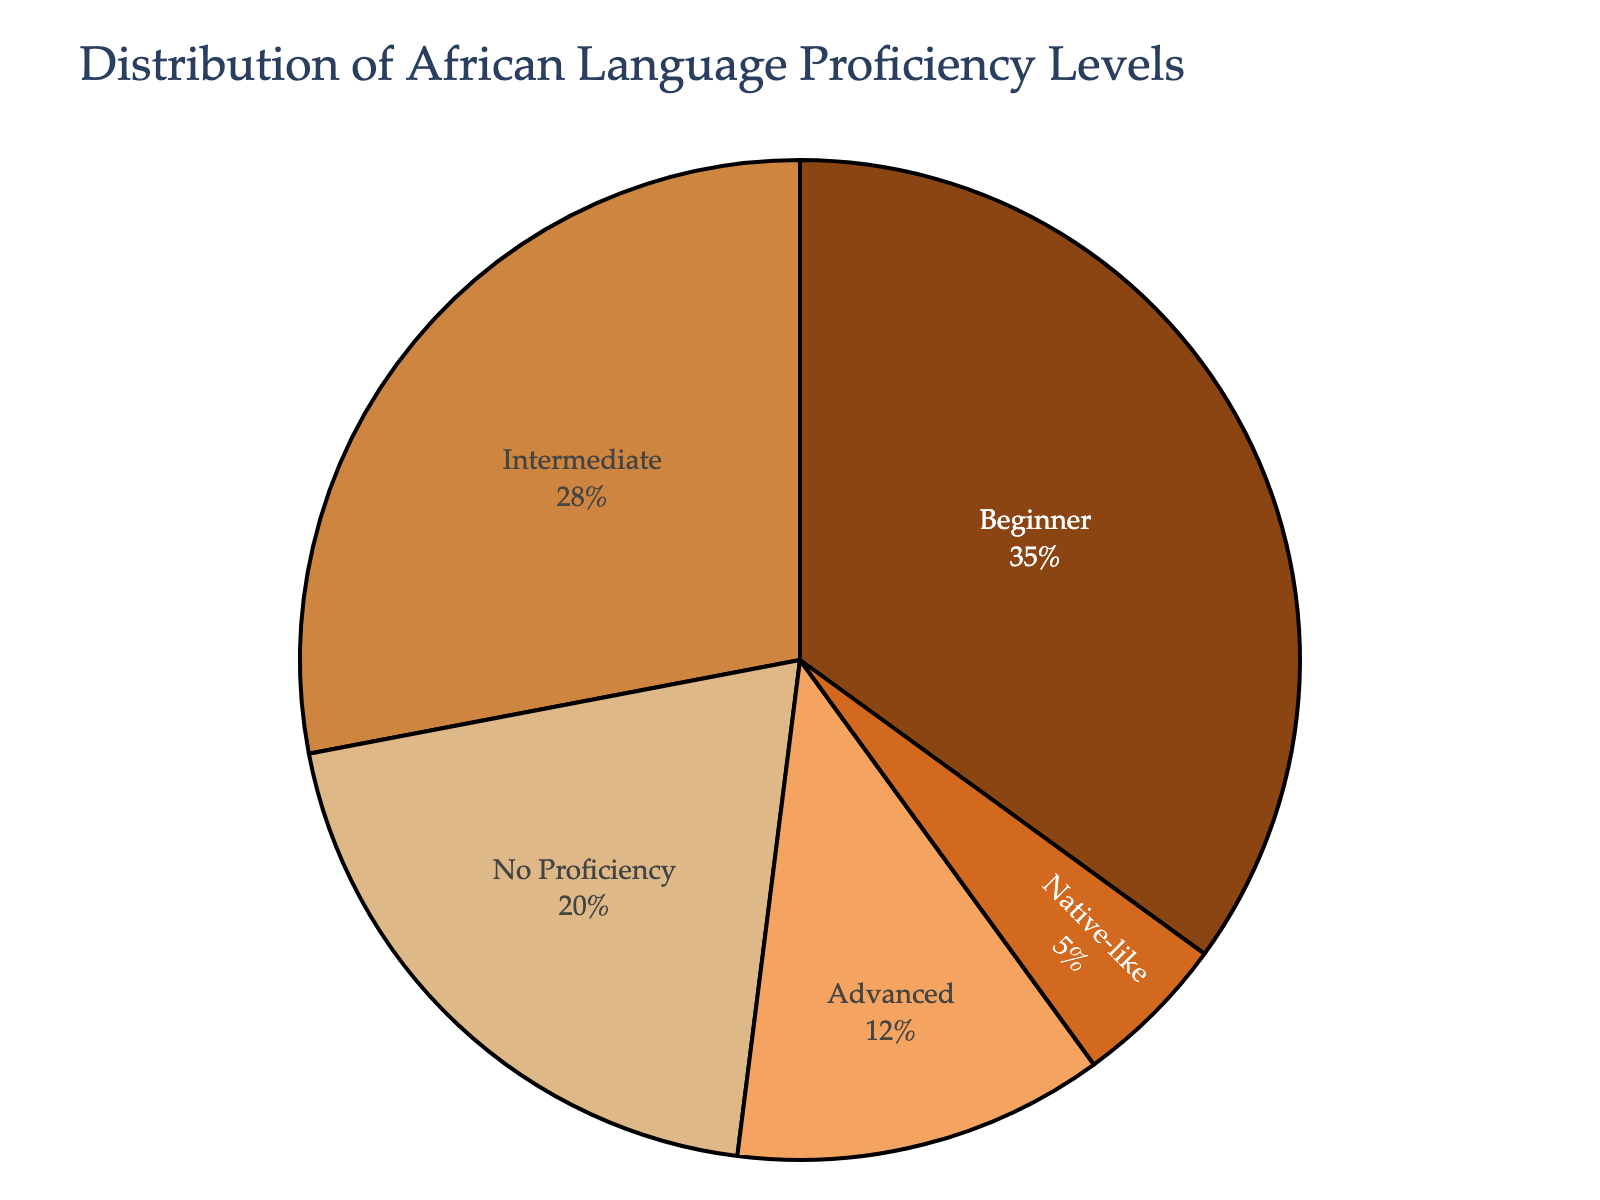What percentage of learners have intermediate proficiency? From the pie chart, we can see the segment labeled "Intermediate" showing its percentage, which is 28%.
Answer: 28% What is the combined percentage of learners at advanced and native-like proficiency levels? First, find the percentages for "Advanced" and "Native-like" from the chart, which are 12% and 5% respectively. Add these values: 12% + 5% = 17%.
Answer: 17% What is the difference in percentage between beginners and those with no proficiency? Identify the percentages of "Beginner" which is 35% and "No Proficiency" which is 20%. Calculate the difference: 35% - 20% = 15%.
Answer: 15% Which proficiency level has the smallest percentage of learners? Look for the segment that takes up the least amount of space in the pie chart. The smallest segment is for "Native-like" which is 5%.
Answer: Native-like Which proficiency level represents the largest group of learners? Determine which segment of the pie chart is the largest. The segment labeled "Beginner" is the largest, with 35%.
Answer: Beginner Compare the number of learners with native-like proficiency to those with advanced proficiency. Which group is larger? Look at the two segments labeled "Native-like" (5%) and "Advanced" (12%). Since 12% is greater than 5%, the "Advanced" group is larger.
Answer: Advanced Are there more learners with some proficiency (beginner, intermediate, advanced, or native-like) or no proficiency at all? Add the percentages for "Beginner" (35%), "Intermediate" (28%), "Advanced" (12%), and "Native-like" (5%), giving 35% + 28% + 12% + 5% = 80%. Compare this with the "No Proficiency" percentage which is 20%. Since 80% is greater than 20%, more learners have some proficiency.
Answer: Some proficiency Determine the ratio of learners with intermediate proficiency to those with no proficiency. From the chart, “Intermediate” is 28% and “No Proficiency” is 20%. The ratio is therefore 28:20, which simplifies to 7:5.
Answer: 7:5 What proportion of the learners belong to the advanced and native-like categories combined compared to the entire group? The combined percentage of "Advanced" and "Native-like" is 17%. Since the total group is represented as 100%, the proportion is 17 out of 100 or 17/100.
Answer: 17/100 How many categories have a percentage below 30%? Identify the categories with percentages below 30%: "Advanced" (12%), "Native-like" (5%), and "No Proficiency" (20%). There are 3 such categories.
Answer: 3 